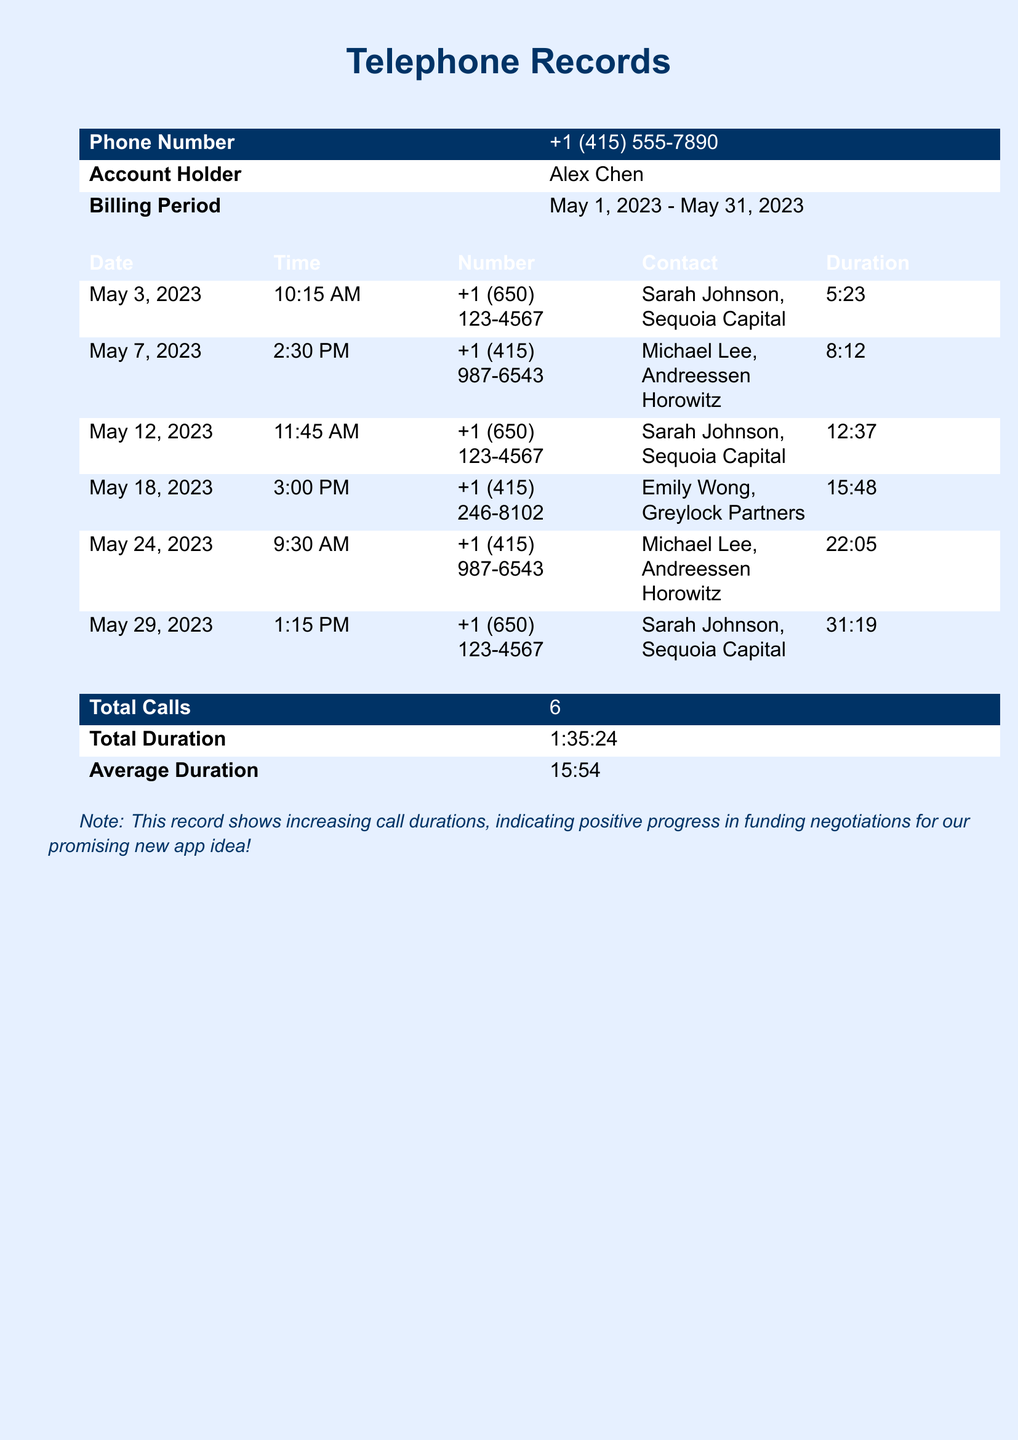What is the phone number of the account holder? The phone number associated with account holder Alex Chen is provided in the document.
Answer: +1 (415) 555-7890 Who is the contact for the longest call? The longest call duration is listed under the contact details for one of the calls.
Answer: Sarah Johnson, Sequoia Capital What date was the call with Emily Wong? The specific date of the call with Emily Wong is indicated in the record.
Answer: May 18, 2023 What is the total duration of all calls? The total duration sums up all the individual call durations recorded in the document.
Answer: 1:35:24 How long was the call on May 24, 2023? The duration of the specific call on this date is mentioned under that entry.
Answer: 22:05 Which venture capitalist was contacted most frequently? By checking the contact names in the records, we can determine which appears the most often.
Answer: Sarah Johnson, Sequoia Capital What is the average duration of the calls? The average duration is calculated based on the total duration divided by the number of calls.
Answer: 15:54 How many calls are listed in total? The document provides a specific count of all calls recorded.
Answer: 6 